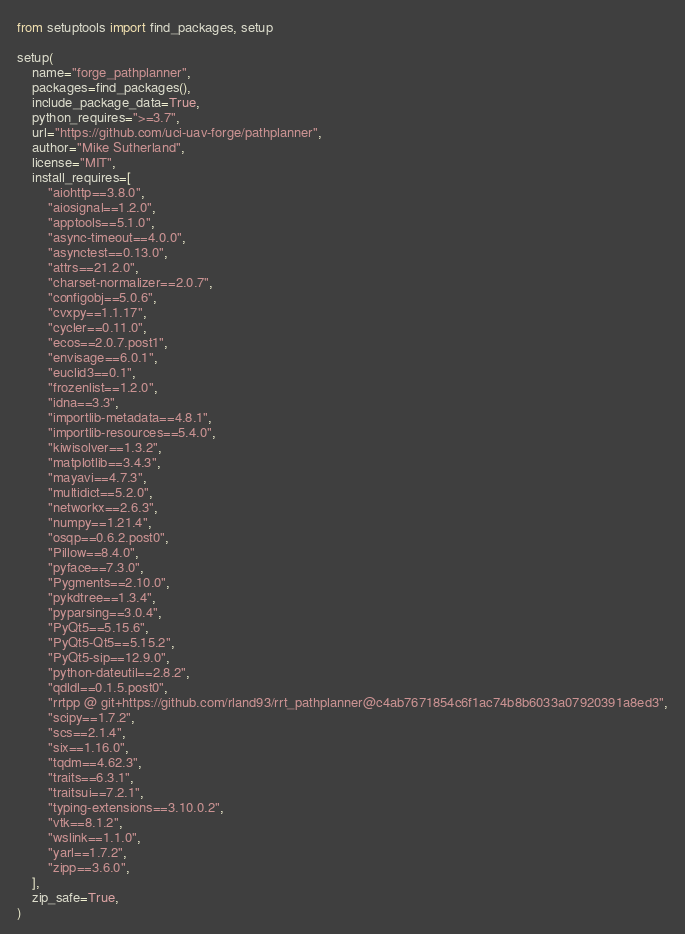Convert code to text. <code><loc_0><loc_0><loc_500><loc_500><_Python_>from setuptools import find_packages, setup

setup(
    name="forge_pathplanner",
    packages=find_packages(),
    include_package_data=True,
    python_requires=">=3.7",
    url="https://github.com/uci-uav-forge/pathplanner",
    author="Mike Sutherland",
    license="MIT",
    install_requires=[
        "aiohttp==3.8.0",
        "aiosignal==1.2.0",
        "apptools==5.1.0",
        "async-timeout==4.0.0",
        "asynctest==0.13.0",
        "attrs==21.2.0",
        "charset-normalizer==2.0.7",
        "configobj==5.0.6",
        "cvxpy==1.1.17",
        "cycler==0.11.0",
        "ecos==2.0.7.post1",
        "envisage==6.0.1",
        "euclid3==0.1",
        "frozenlist==1.2.0",
        "idna==3.3",
        "importlib-metadata==4.8.1",
        "importlib-resources==5.4.0",
        "kiwisolver==1.3.2",
        "matplotlib==3.4.3",
        "mayavi==4.7.3",
        "multidict==5.2.0",
        "networkx==2.6.3",
        "numpy==1.21.4",
        "osqp==0.6.2.post0",
        "Pillow==8.4.0",
        "pyface==7.3.0",
        "Pygments==2.10.0",
        "pykdtree==1.3.4",
        "pyparsing==3.0.4",
        "PyQt5==5.15.6",
        "PyQt5-Qt5==5.15.2",
        "PyQt5-sip==12.9.0",
        "python-dateutil==2.8.2",
        "qdldl==0.1.5.post0",
        "rrtpp @ git+https://github.com/rland93/rrt_pathplanner@c4ab7671854c6f1ac74b8b6033a07920391a8ed3",
        "scipy==1.7.2",
        "scs==2.1.4",
        "six==1.16.0",
        "tqdm==4.62.3",
        "traits==6.3.1",
        "traitsui==7.2.1",
        "typing-extensions==3.10.0.2",
        "vtk==8.1.2",
        "wslink==1.1.0",
        "yarl==1.7.2",
        "zipp==3.6.0",
    ],
    zip_safe=True,
)</code> 